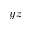Convert formula to latex. <formula><loc_0><loc_0><loc_500><loc_500>y z</formula> 